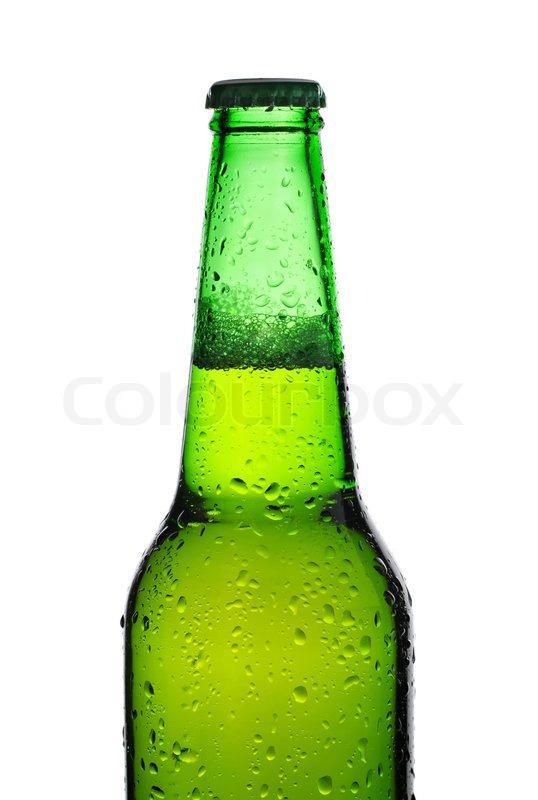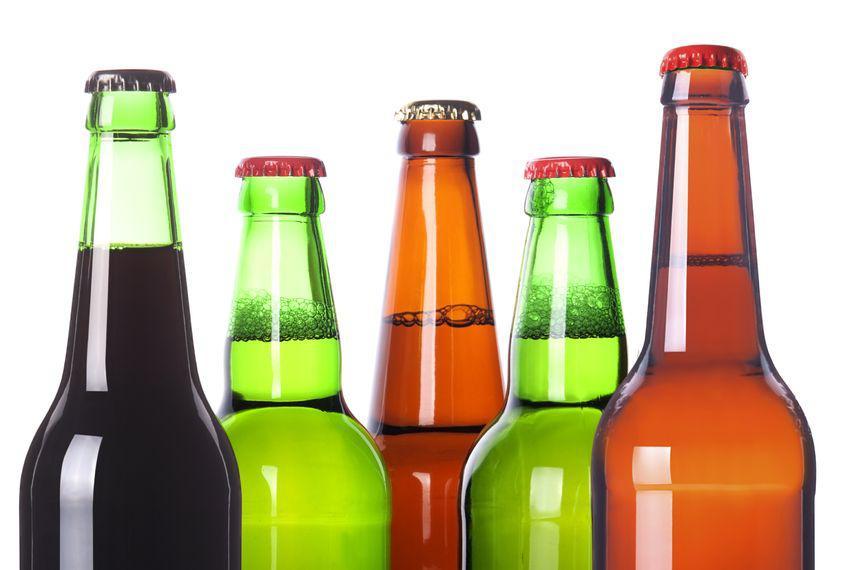The first image is the image on the left, the second image is the image on the right. Evaluate the accuracy of this statement regarding the images: "There are no more than six glass bottles". Is it true? Answer yes or no. Yes. 